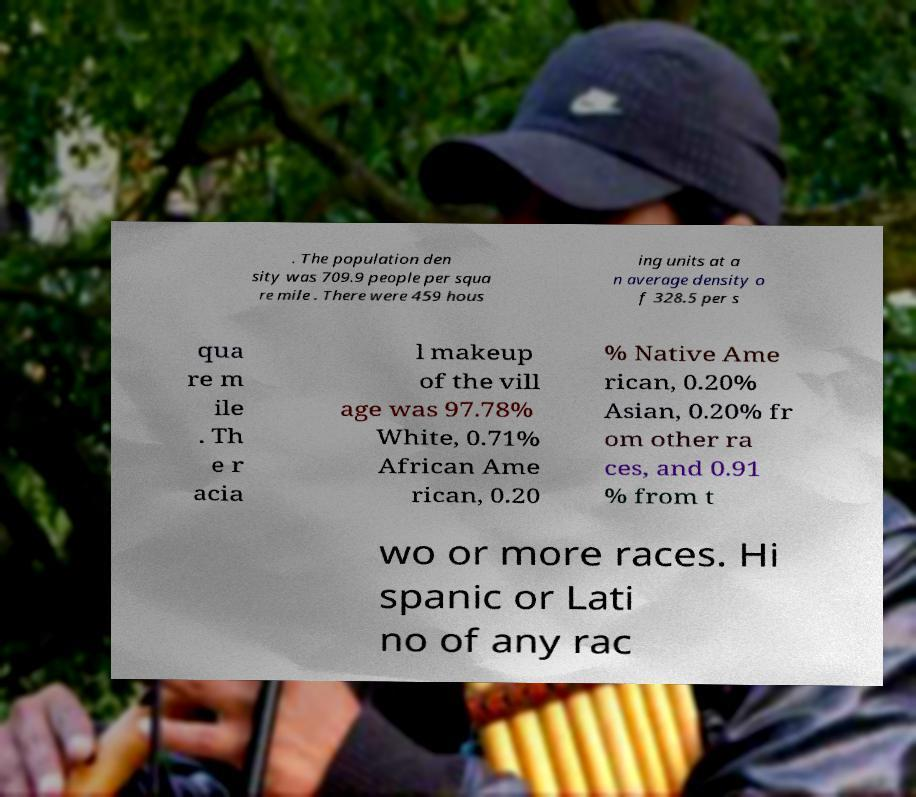Please identify and transcribe the text found in this image. . The population den sity was 709.9 people per squa re mile . There were 459 hous ing units at a n average density o f 328.5 per s qua re m ile . Th e r acia l makeup of the vill age was 97.78% White, 0.71% African Ame rican, 0.20 % Native Ame rican, 0.20% Asian, 0.20% fr om other ra ces, and 0.91 % from t wo or more races. Hi spanic or Lati no of any rac 